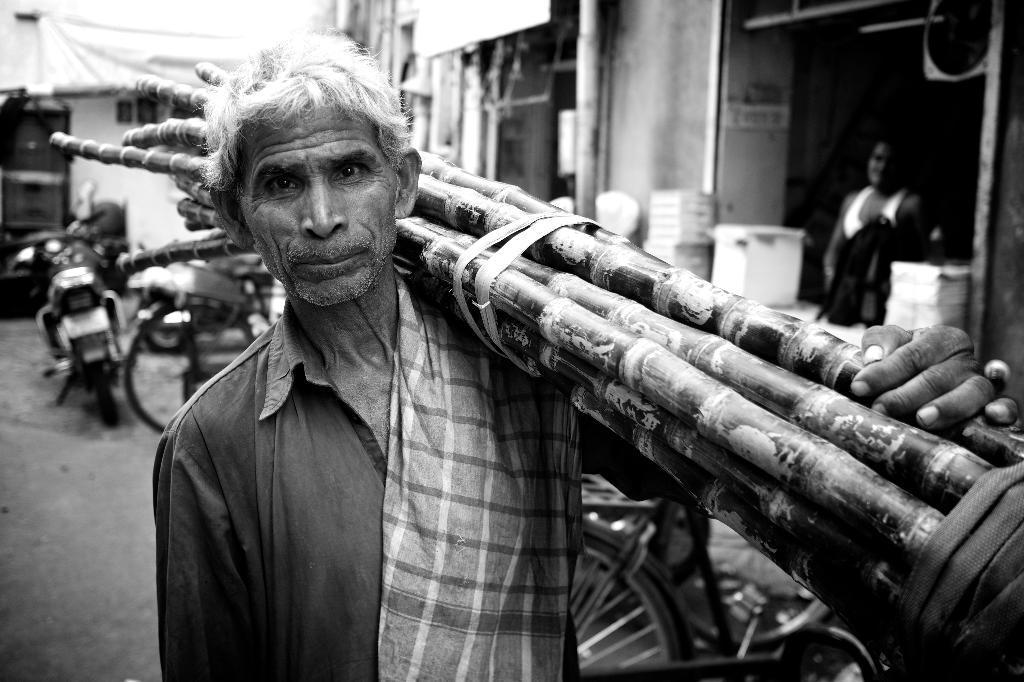Could you give a brief overview of what you see in this image? In the middle of the image a man is standing and holding some sticks. Behind him there are some bicycles and motorcycle. At the top of the image there are some buildings, in the building a person is standing. 